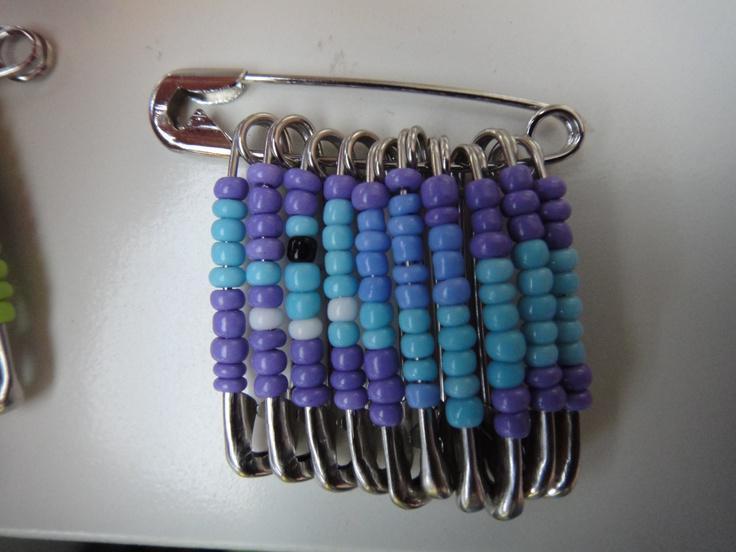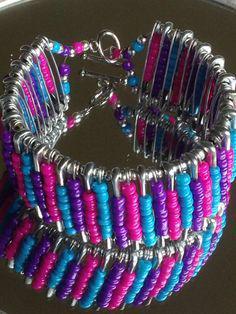The first image is the image on the left, the second image is the image on the right. Examine the images to the left and right. Is the description "One image shows a safety pin bracelet displayed on a flat surface, and the other image shows a safety pin strung with colored beads that form an animal image." accurate? Answer yes or no. Yes. The first image is the image on the left, the second image is the image on the right. Considering the images on both sides, is "the beads hanging from the safety pin to the left are mostly purple and blue" valid? Answer yes or no. Yes. 